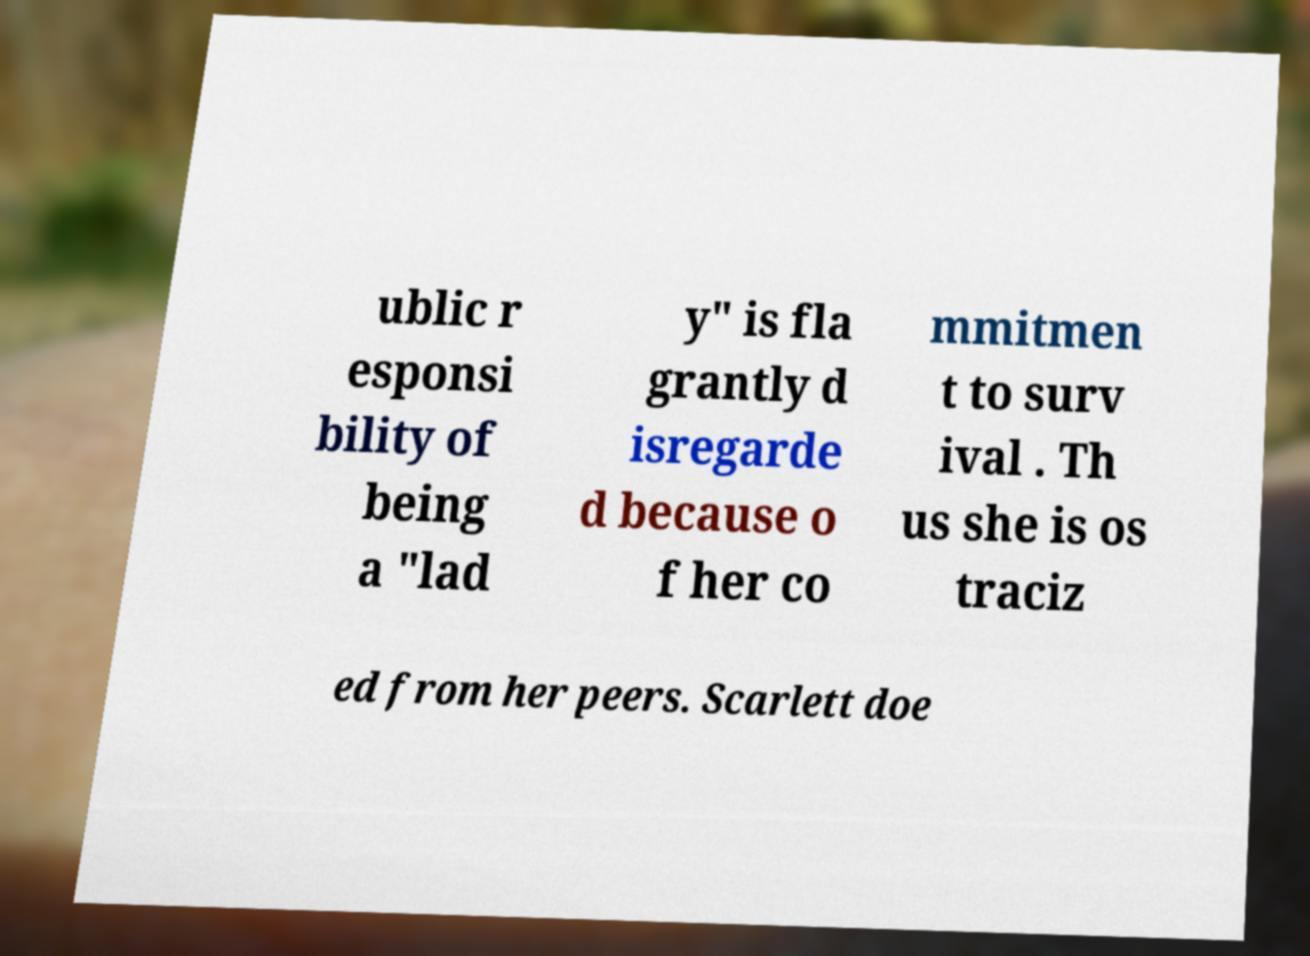Can you accurately transcribe the text from the provided image for me? ublic r esponsi bility of being a "lad y" is fla grantly d isregarde d because o f her co mmitmen t to surv ival . Th us she is os traciz ed from her peers. Scarlett doe 